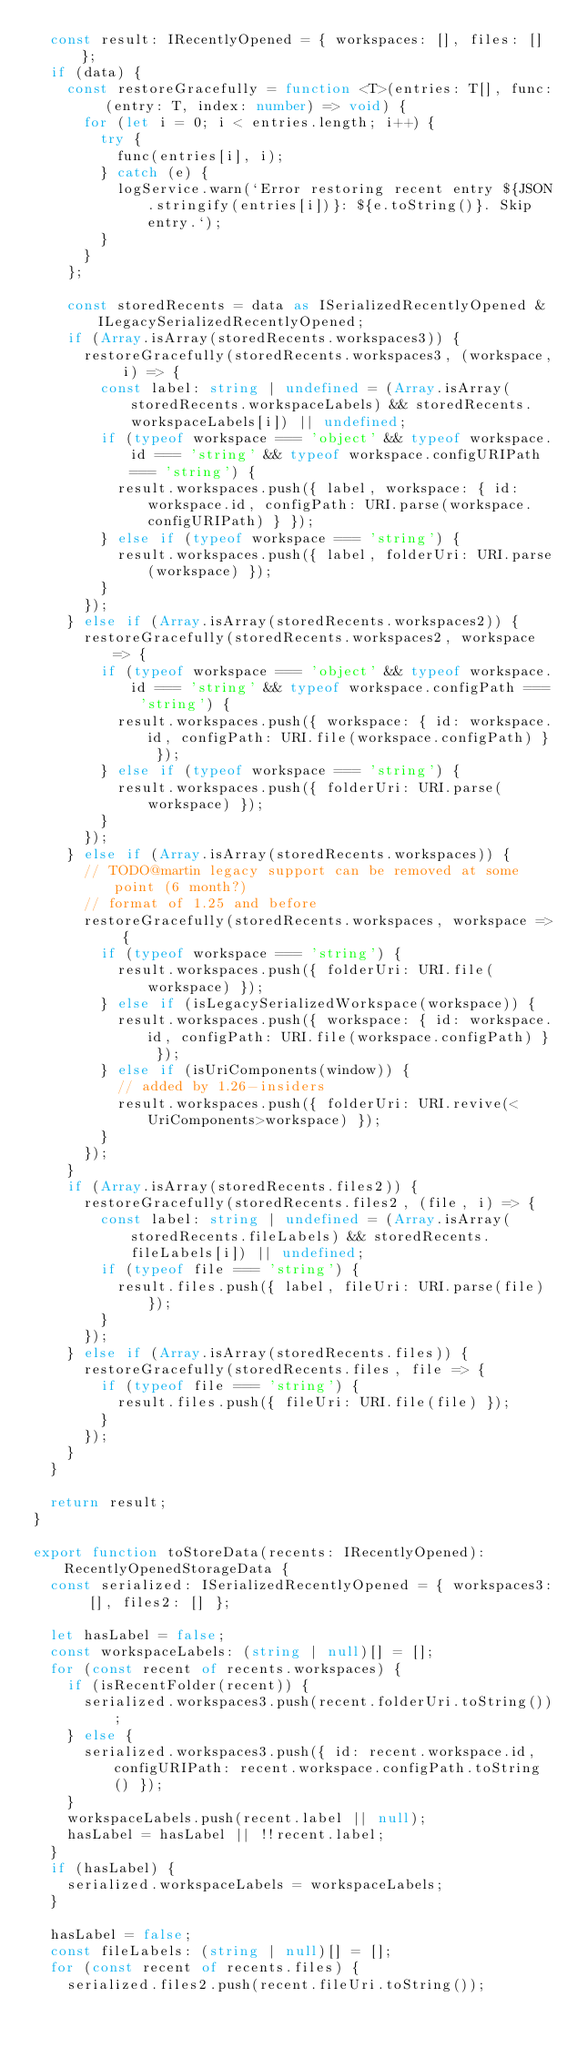Convert code to text. <code><loc_0><loc_0><loc_500><loc_500><_TypeScript_>	const result: IRecentlyOpened = { workspaces: [], files: [] };
	if (data) {
		const restoreGracefully = function <T>(entries: T[], func: (entry: T, index: number) => void) {
			for (let i = 0; i < entries.length; i++) {
				try {
					func(entries[i], i);
				} catch (e) {
					logService.warn(`Error restoring recent entry ${JSON.stringify(entries[i])}: ${e.toString()}. Skip entry.`);
				}
			}
		};

		const storedRecents = data as ISerializedRecentlyOpened & ILegacySerializedRecentlyOpened;
		if (Array.isArray(storedRecents.workspaces3)) {
			restoreGracefully(storedRecents.workspaces3, (workspace, i) => {
				const label: string | undefined = (Array.isArray(storedRecents.workspaceLabels) && storedRecents.workspaceLabels[i]) || undefined;
				if (typeof workspace === 'object' && typeof workspace.id === 'string' && typeof workspace.configURIPath === 'string') {
					result.workspaces.push({ label, workspace: { id: workspace.id, configPath: URI.parse(workspace.configURIPath) } });
				} else if (typeof workspace === 'string') {
					result.workspaces.push({ label, folderUri: URI.parse(workspace) });
				}
			});
		} else if (Array.isArray(storedRecents.workspaces2)) {
			restoreGracefully(storedRecents.workspaces2, workspace => {
				if (typeof workspace === 'object' && typeof workspace.id === 'string' && typeof workspace.configPath === 'string') {
					result.workspaces.push({ workspace: { id: workspace.id, configPath: URI.file(workspace.configPath) } });
				} else if (typeof workspace === 'string') {
					result.workspaces.push({ folderUri: URI.parse(workspace) });
				}
			});
		} else if (Array.isArray(storedRecents.workspaces)) {
			// TODO@martin legacy support can be removed at some point (6 month?)
			// format of 1.25 and before
			restoreGracefully(storedRecents.workspaces, workspace => {
				if (typeof workspace === 'string') {
					result.workspaces.push({ folderUri: URI.file(workspace) });
				} else if (isLegacySerializedWorkspace(workspace)) {
					result.workspaces.push({ workspace: { id: workspace.id, configPath: URI.file(workspace.configPath) } });
				} else if (isUriComponents(window)) {
					// added by 1.26-insiders
					result.workspaces.push({ folderUri: URI.revive(<UriComponents>workspace) });
				}
			});
		}
		if (Array.isArray(storedRecents.files2)) {
			restoreGracefully(storedRecents.files2, (file, i) => {
				const label: string | undefined = (Array.isArray(storedRecents.fileLabels) && storedRecents.fileLabels[i]) || undefined;
				if (typeof file === 'string') {
					result.files.push({ label, fileUri: URI.parse(file) });
				}
			});
		} else if (Array.isArray(storedRecents.files)) {
			restoreGracefully(storedRecents.files, file => {
				if (typeof file === 'string') {
					result.files.push({ fileUri: URI.file(file) });
				}
			});
		}
	}

	return result;
}

export function toStoreData(recents: IRecentlyOpened): RecentlyOpenedStorageData {
	const serialized: ISerializedRecentlyOpened = { workspaces3: [], files2: [] };

	let hasLabel = false;
	const workspaceLabels: (string | null)[] = [];
	for (const recent of recents.workspaces) {
		if (isRecentFolder(recent)) {
			serialized.workspaces3.push(recent.folderUri.toString());
		} else {
			serialized.workspaces3.push({ id: recent.workspace.id, configURIPath: recent.workspace.configPath.toString() });
		}
		workspaceLabels.push(recent.label || null);
		hasLabel = hasLabel || !!recent.label;
	}
	if (hasLabel) {
		serialized.workspaceLabels = workspaceLabels;
	}

	hasLabel = false;
	const fileLabels: (string | null)[] = [];
	for (const recent of recents.files) {
		serialized.files2.push(recent.fileUri.toString());</code> 